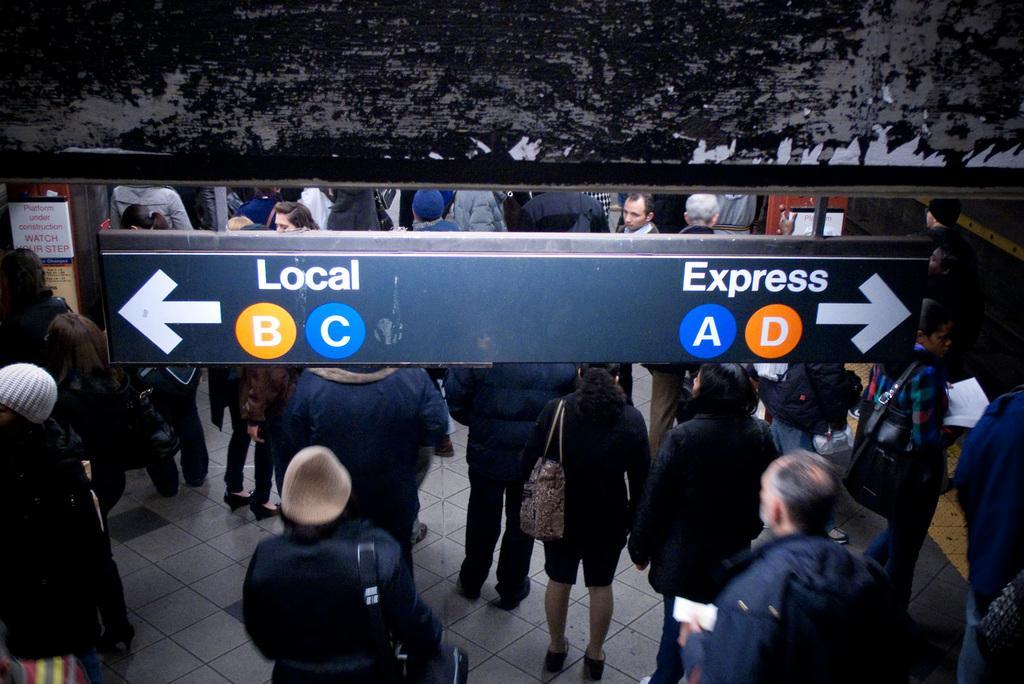Describe this image in one or two sentences. In this image I can see group of people standing and few people are wearing bag. They are wearing different color dress. In front I can see a blue color board and something is written on it. 